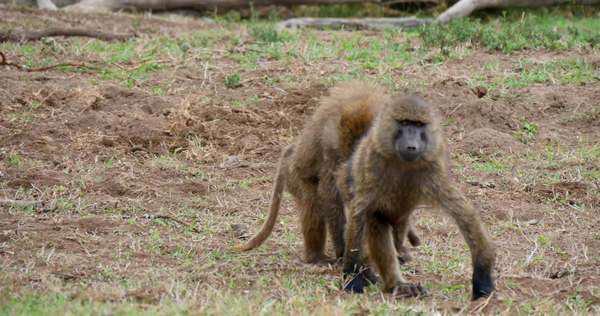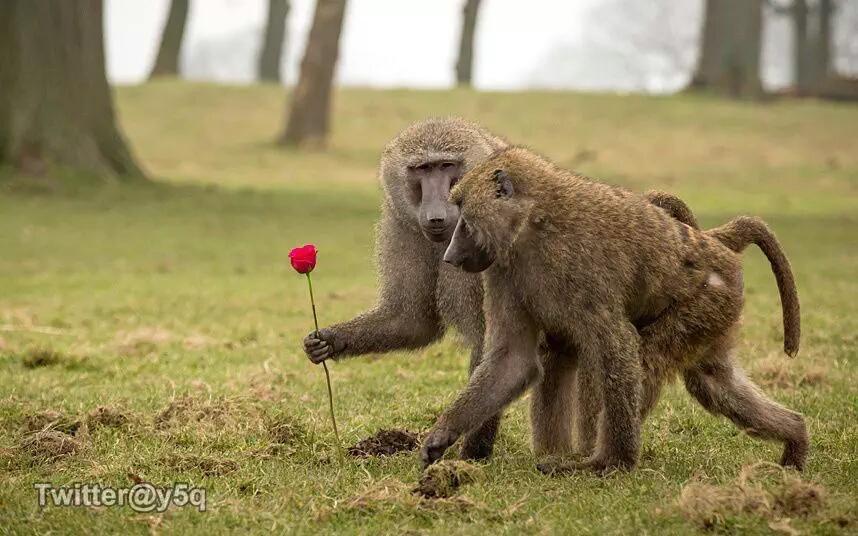The first image is the image on the left, the second image is the image on the right. Considering the images on both sides, is "there are no more than 4 baboons in the pair of images" valid? Answer yes or no. Yes. The first image is the image on the left, the second image is the image on the right. For the images shown, is this caption "in the right side the primate has something in its hands" true? Answer yes or no. Yes. The first image is the image on the left, the second image is the image on the right. Examine the images to the left and right. Is the description "A monkey in the image on the right happens to be holding something." accurate? Answer yes or no. Yes. 